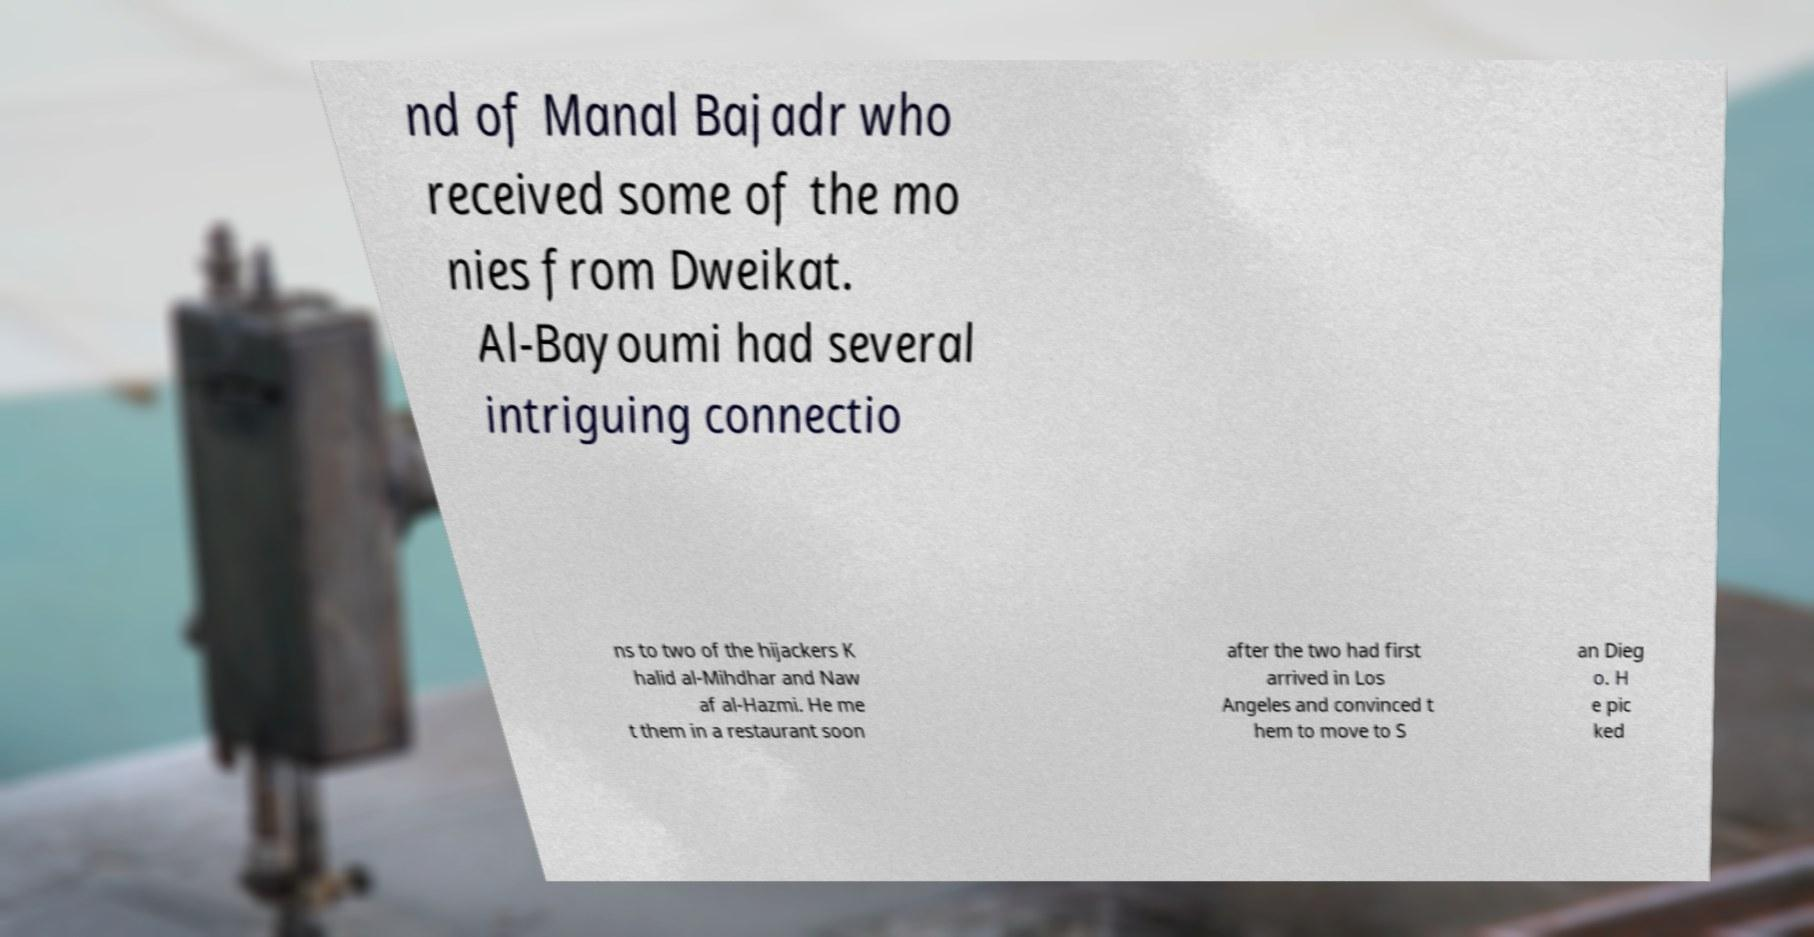Can you accurately transcribe the text from the provided image for me? nd of Manal Bajadr who received some of the mo nies from Dweikat. Al-Bayoumi had several intriguing connectio ns to two of the hijackers K halid al-Mihdhar and Naw af al-Hazmi. He me t them in a restaurant soon after the two had first arrived in Los Angeles and convinced t hem to move to S an Dieg o. H e pic ked 